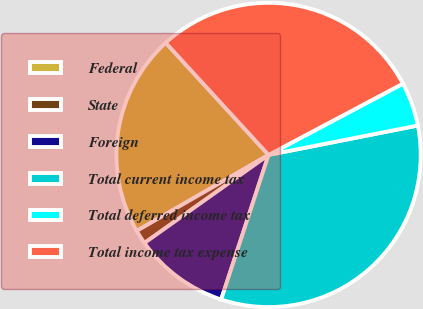<chart> <loc_0><loc_0><loc_500><loc_500><pie_chart><fcel>Federal<fcel>State<fcel>Foreign<fcel>Total current income tax<fcel>Total deferred income tax<fcel>Total income tax expense<nl><fcel>21.51%<fcel>1.5%<fcel>10.14%<fcel>33.14%<fcel>4.66%<fcel>29.05%<nl></chart> 